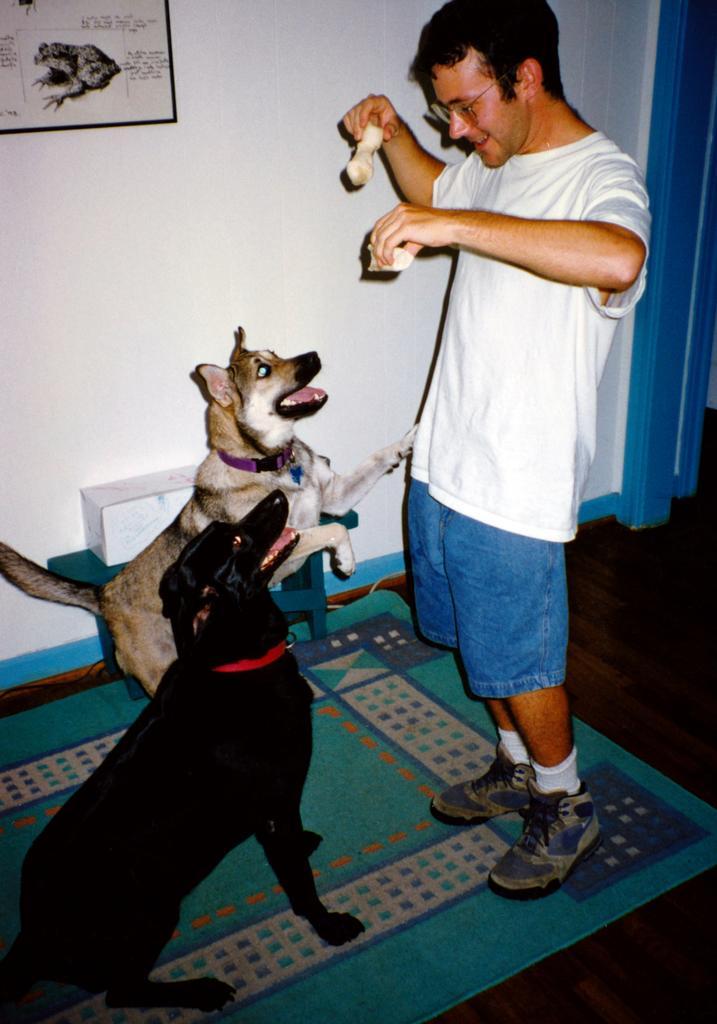Could you give a brief overview of what you see in this image? In this image we can see two dogs. A person is holding some objects in his hand. There is a stool and an object placed on it. There is a mat on the floor. There is a door in the image. There is an object on the wall in the image. 